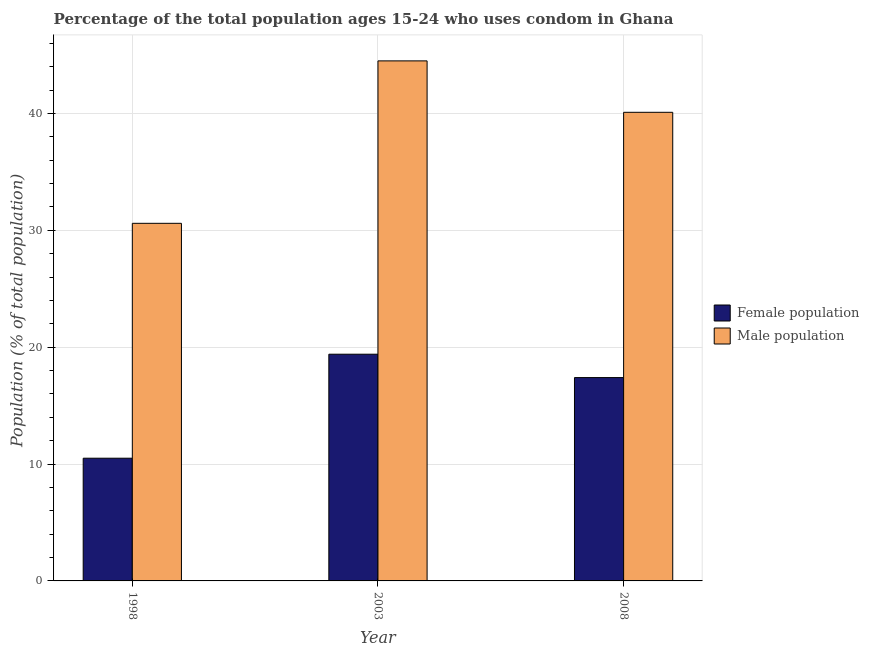How many groups of bars are there?
Provide a succinct answer. 3. Are the number of bars per tick equal to the number of legend labels?
Your response must be concise. Yes. Are the number of bars on each tick of the X-axis equal?
Your answer should be very brief. Yes. How many bars are there on the 3rd tick from the left?
Provide a succinct answer. 2. What is the label of the 3rd group of bars from the left?
Your answer should be very brief. 2008. What is the male population in 2003?
Give a very brief answer. 44.5. Across all years, what is the maximum female population?
Your response must be concise. 19.4. Across all years, what is the minimum male population?
Give a very brief answer. 30.6. In which year was the male population maximum?
Offer a terse response. 2003. What is the total male population in the graph?
Your answer should be compact. 115.2. What is the difference between the female population in 1998 and that in 2008?
Your answer should be compact. -6.9. What is the difference between the male population in 2008 and the female population in 2003?
Ensure brevity in your answer.  -4.4. What is the average male population per year?
Give a very brief answer. 38.4. What is the ratio of the male population in 2003 to that in 2008?
Offer a very short reply. 1.11. What is the difference between the highest and the lowest female population?
Your answer should be compact. 8.9. In how many years, is the female population greater than the average female population taken over all years?
Provide a short and direct response. 2. Is the sum of the male population in 1998 and 2008 greater than the maximum female population across all years?
Provide a succinct answer. Yes. What does the 1st bar from the left in 1998 represents?
Your response must be concise. Female population. What does the 1st bar from the right in 2008 represents?
Offer a terse response. Male population. How many bars are there?
Provide a short and direct response. 6. What is the difference between two consecutive major ticks on the Y-axis?
Give a very brief answer. 10. Are the values on the major ticks of Y-axis written in scientific E-notation?
Your answer should be compact. No. Does the graph contain any zero values?
Your response must be concise. No. How are the legend labels stacked?
Give a very brief answer. Vertical. What is the title of the graph?
Give a very brief answer. Percentage of the total population ages 15-24 who uses condom in Ghana. Does "RDB nonconcessional" appear as one of the legend labels in the graph?
Give a very brief answer. No. What is the label or title of the X-axis?
Offer a terse response. Year. What is the label or title of the Y-axis?
Your answer should be very brief. Population (% of total population) . What is the Population (% of total population)  of Male population in 1998?
Keep it short and to the point. 30.6. What is the Population (% of total population)  of Female population in 2003?
Your answer should be compact. 19.4. What is the Population (% of total population)  in Male population in 2003?
Your response must be concise. 44.5. What is the Population (% of total population)  in Female population in 2008?
Offer a terse response. 17.4. What is the Population (% of total population)  of Male population in 2008?
Your answer should be very brief. 40.1. Across all years, what is the maximum Population (% of total population)  of Female population?
Provide a succinct answer. 19.4. Across all years, what is the maximum Population (% of total population)  of Male population?
Offer a very short reply. 44.5. Across all years, what is the minimum Population (% of total population)  in Male population?
Make the answer very short. 30.6. What is the total Population (% of total population)  of Female population in the graph?
Keep it short and to the point. 47.3. What is the total Population (% of total population)  of Male population in the graph?
Ensure brevity in your answer.  115.2. What is the difference between the Population (% of total population)  in Female population in 1998 and that in 2003?
Your response must be concise. -8.9. What is the difference between the Population (% of total population)  in Male population in 2003 and that in 2008?
Provide a succinct answer. 4.4. What is the difference between the Population (% of total population)  in Female population in 1998 and the Population (% of total population)  in Male population in 2003?
Give a very brief answer. -34. What is the difference between the Population (% of total population)  in Female population in 1998 and the Population (% of total population)  in Male population in 2008?
Provide a succinct answer. -29.6. What is the difference between the Population (% of total population)  of Female population in 2003 and the Population (% of total population)  of Male population in 2008?
Offer a terse response. -20.7. What is the average Population (% of total population)  of Female population per year?
Your answer should be very brief. 15.77. What is the average Population (% of total population)  of Male population per year?
Make the answer very short. 38.4. In the year 1998, what is the difference between the Population (% of total population)  of Female population and Population (% of total population)  of Male population?
Ensure brevity in your answer.  -20.1. In the year 2003, what is the difference between the Population (% of total population)  in Female population and Population (% of total population)  in Male population?
Provide a succinct answer. -25.1. In the year 2008, what is the difference between the Population (% of total population)  of Female population and Population (% of total population)  of Male population?
Your answer should be very brief. -22.7. What is the ratio of the Population (% of total population)  in Female population in 1998 to that in 2003?
Your response must be concise. 0.54. What is the ratio of the Population (% of total population)  in Male population in 1998 to that in 2003?
Your answer should be very brief. 0.69. What is the ratio of the Population (% of total population)  of Female population in 1998 to that in 2008?
Make the answer very short. 0.6. What is the ratio of the Population (% of total population)  in Male population in 1998 to that in 2008?
Provide a short and direct response. 0.76. What is the ratio of the Population (% of total population)  in Female population in 2003 to that in 2008?
Your response must be concise. 1.11. What is the ratio of the Population (% of total population)  in Male population in 2003 to that in 2008?
Offer a very short reply. 1.11. What is the difference between the highest and the second highest Population (% of total population)  of Female population?
Your answer should be very brief. 2. What is the difference between the highest and the second highest Population (% of total population)  in Male population?
Your answer should be very brief. 4.4. What is the difference between the highest and the lowest Population (% of total population)  of Female population?
Make the answer very short. 8.9. 